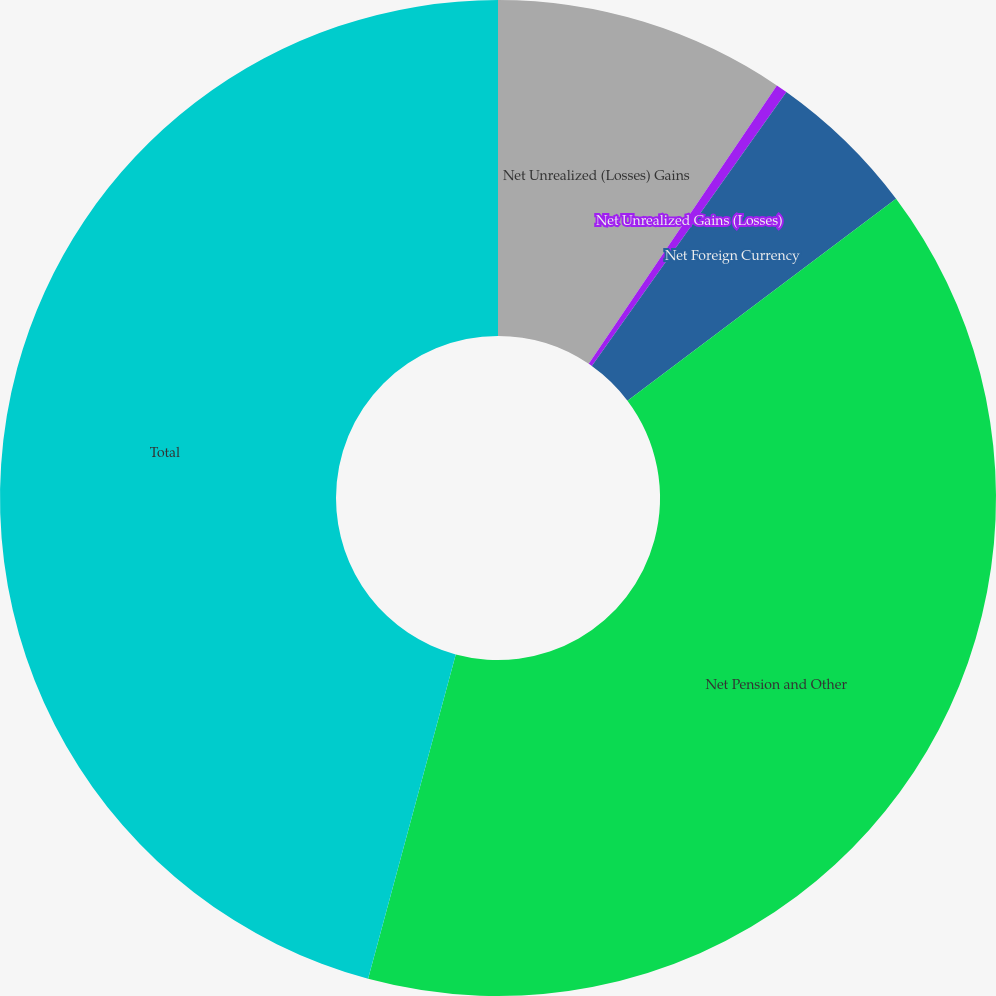Convert chart to OTSL. <chart><loc_0><loc_0><loc_500><loc_500><pie_chart><fcel>Net Unrealized (Losses) Gains<fcel>Net Unrealized Gains (Losses)<fcel>Net Foreign Currency<fcel>Net Pension and Other<fcel>Total<nl><fcel>9.46%<fcel>0.37%<fcel>4.91%<fcel>39.46%<fcel>45.8%<nl></chart> 